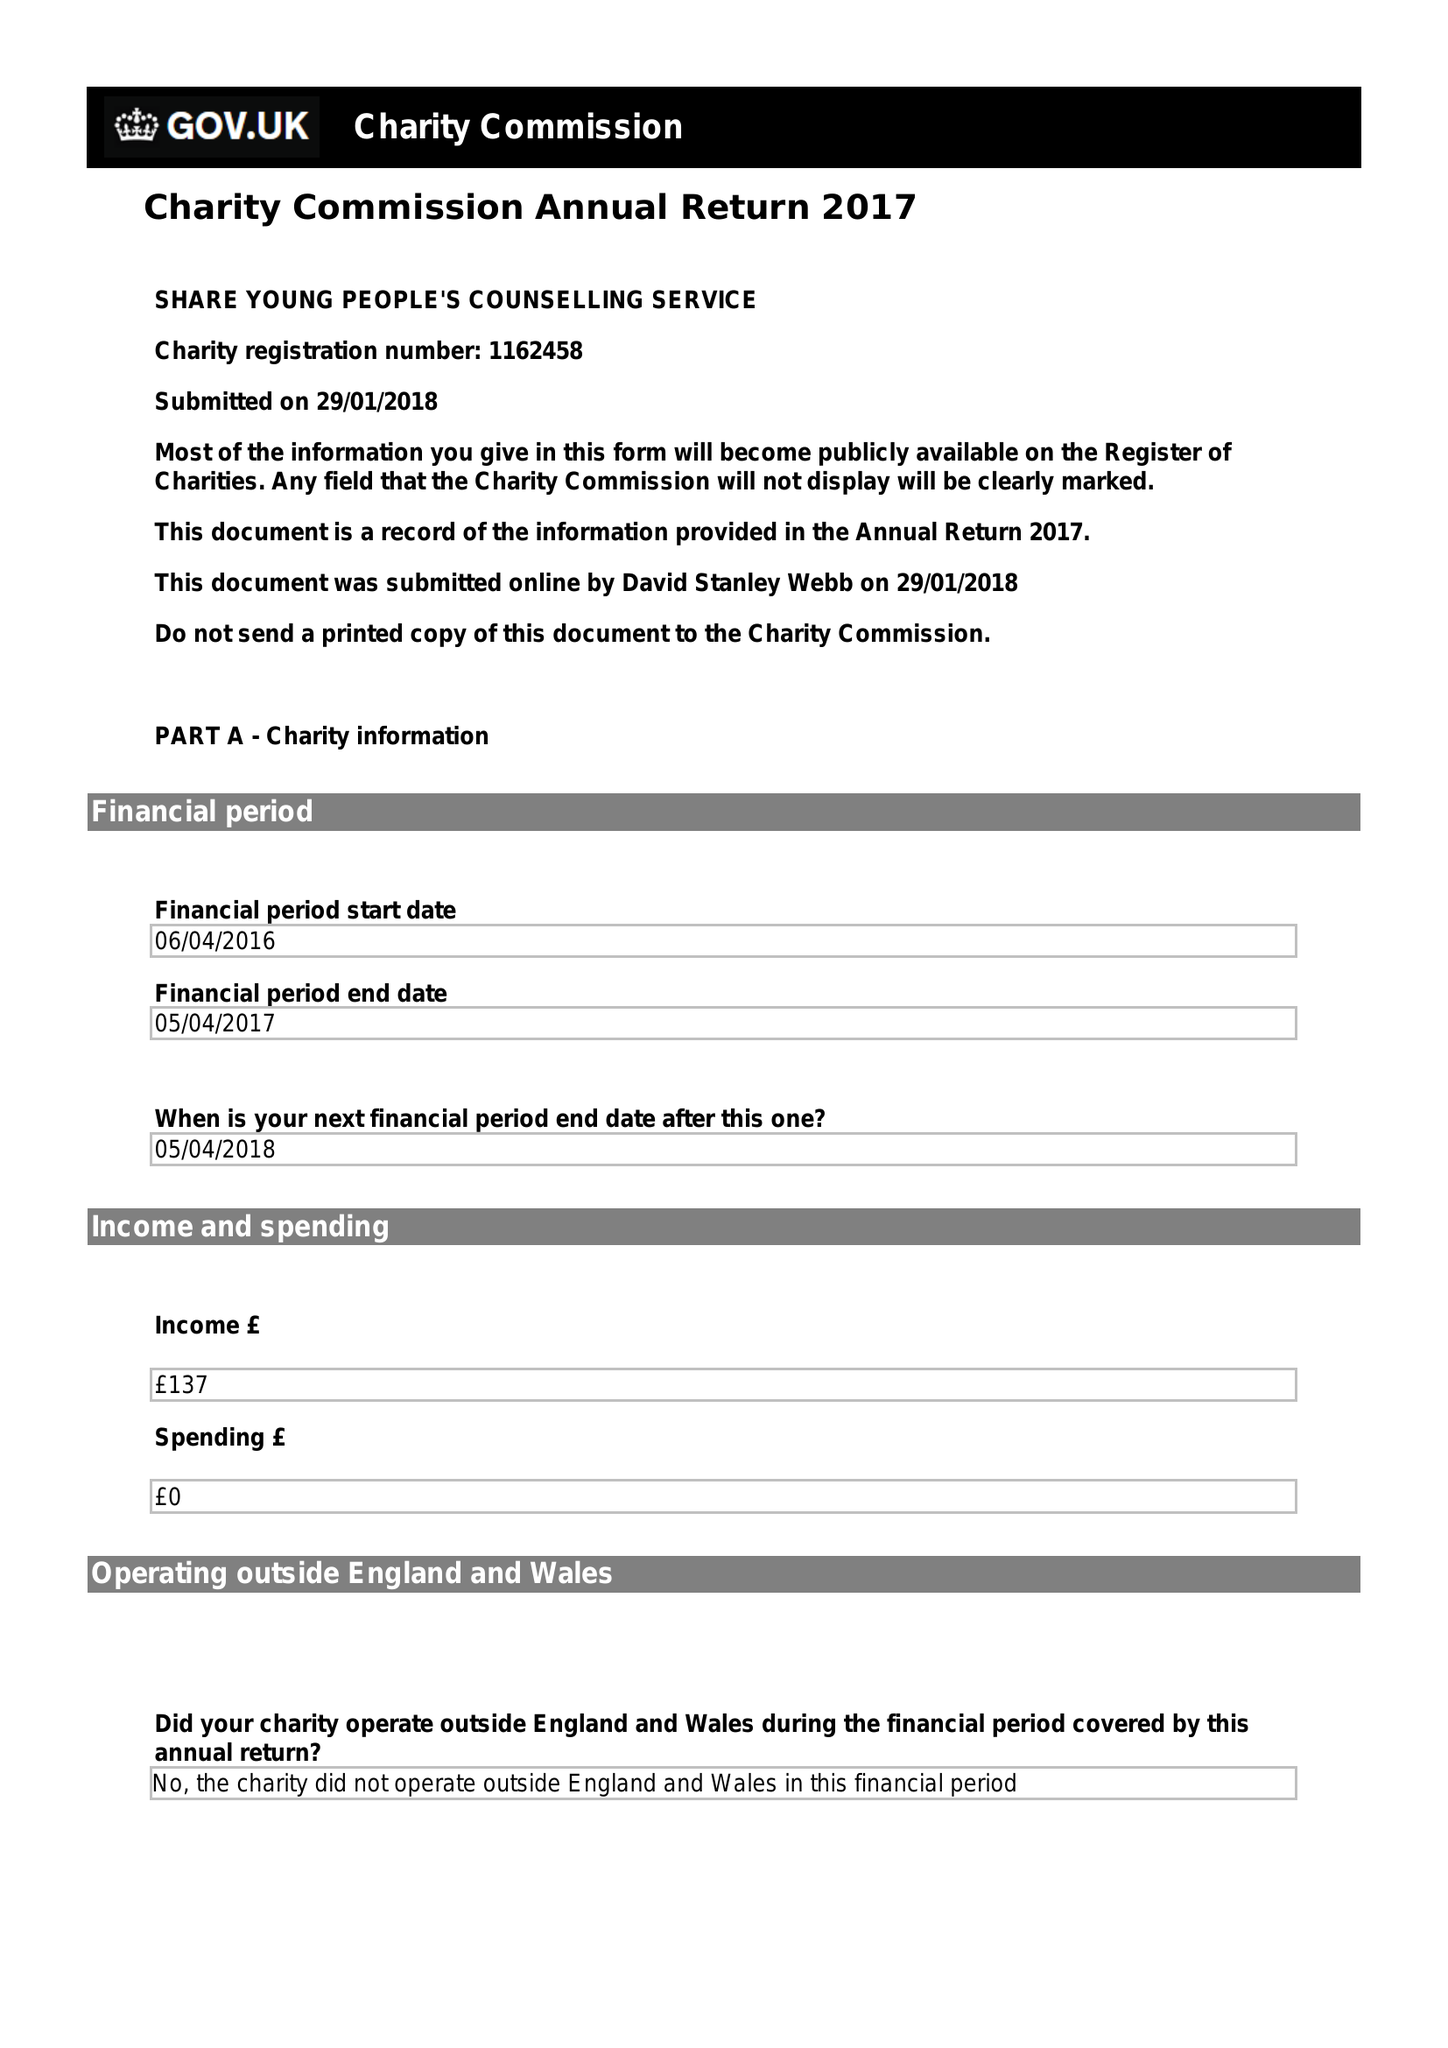What is the value for the charity_number?
Answer the question using a single word or phrase. 1162458 